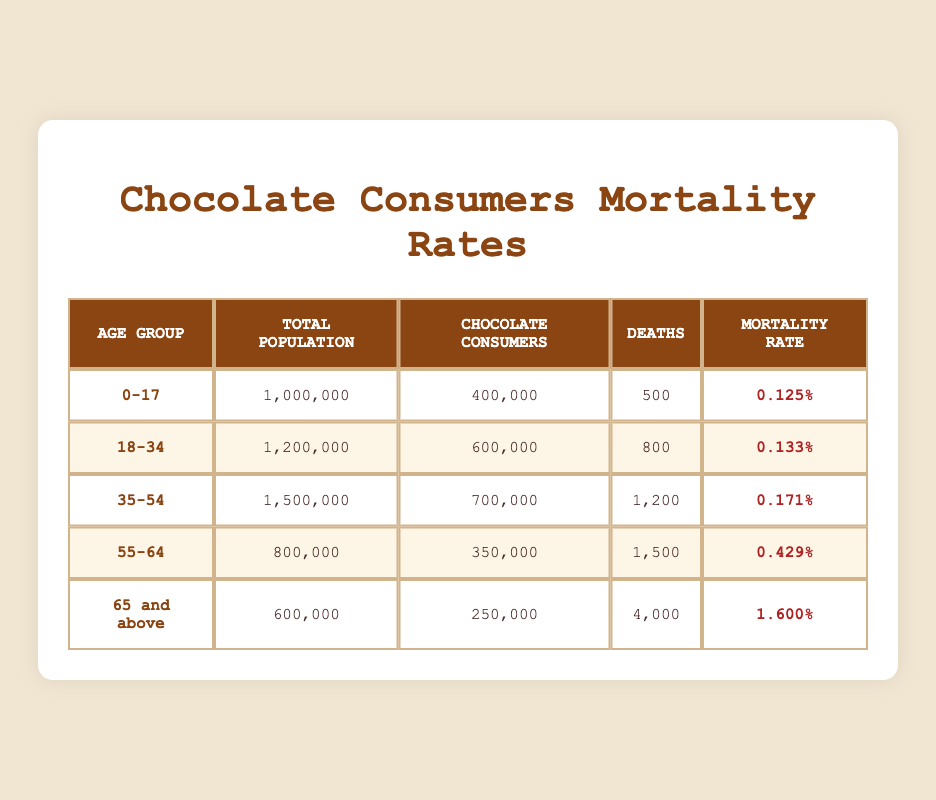What is the mortality rate for the age group 35-54? Referring to the table, the mortality rate for the age group 35-54 is listed as 0.1714%.
Answer: 0.1714% How many deaths occurred among chocolate consumers aged 65 and above? According to the table, there were 4000 deaths in the age group 65 and above.
Answer: 4000 What is the total population of chocolate consumers in the age group 18-34? The table indicates that the total population of chocolate consumers in the age group 18-34 is 600,000.
Answer: 600,000 Which age group has the highest mortality rate? When looking at the mortality rates, the age group 65 and above has the highest rate at 1.6%.
Answer: 65 and above What is the total number of chocolate consumers in all age groups? We sum the chocolate consumers across all age groups: 400,000 (0-17) + 600,000 (18-34) + 700,000 (35-54) + 350,000 (55-64) + 250,000 (65 and above) = 2,900,000.
Answer: 2,900,000 Is the mortality rate for age group 55-64 higher than that of age group 18-34? Comparing the two rates, the mortality rate for 55-64 is 0.4286%, which is higher than the 0.1333% for 18-34. Thus, the statement is true.
Answer: Yes What percentage of the total population aged 0-17 are chocolate consumers? To find this percentage, we divide the number of chocolate consumers (400,000) by the total population (1,000,000) and multiply by 100: (400,000 / 1,000,000) * 100 = 40%.
Answer: 40% If we look at the deaths per thousand consumers, which age group has the highest? For each age group, we calculate deaths per thousand chocolate consumers: 
- 0-17: (500 / 400,000) * 1000 = 1.25
- 18-34: (800 / 600,000) * 1000 = 1.33
- 35-54: (1200 / 700,000) * 1000 = 1.71
- 55-64: (1500 / 350,000) * 1000 = 4.29
- 65 and above: (4000 / 250,000) * 1000 = 16
The highest is for the age group 65 and above at 16 deaths per thousand consumers.
Answer: 65 and above What is the average mortality rate across all age groups? To calculate the average mortality rate, we sum the rates: (0.125 + 0.1333 + 0.1714 + 0.4286 + 1.6) = 2.4583, then divide by 5 (the number of age groups): 2.4583 / 5 = 0.49166%.
Answer: 0.49166% 